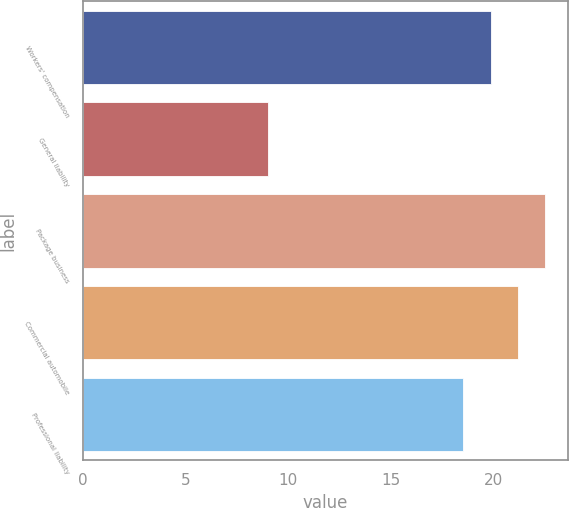<chart> <loc_0><loc_0><loc_500><loc_500><bar_chart><fcel>Workers' compensation<fcel>General liability<fcel>Package business<fcel>Commercial automobile<fcel>Professional liability<nl><fcel>19.9<fcel>9<fcel>22.5<fcel>21.2<fcel>18.5<nl></chart> 